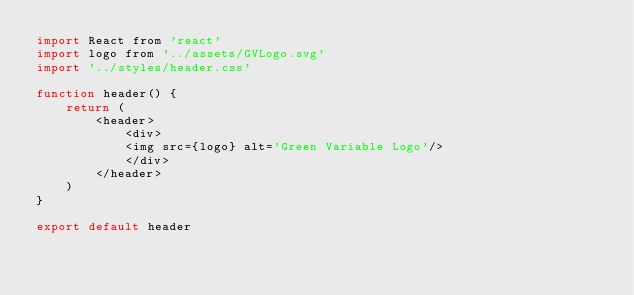Convert code to text. <code><loc_0><loc_0><loc_500><loc_500><_JavaScript_>import React from 'react'
import logo from '../assets/GVLogo.svg'
import '../styles/header.css'

function header() {
    return (
        <header>
            <div>
            <img src={logo} alt='Green Variable Logo'/>
            </div>
        </header>
    )
}

export default header
</code> 